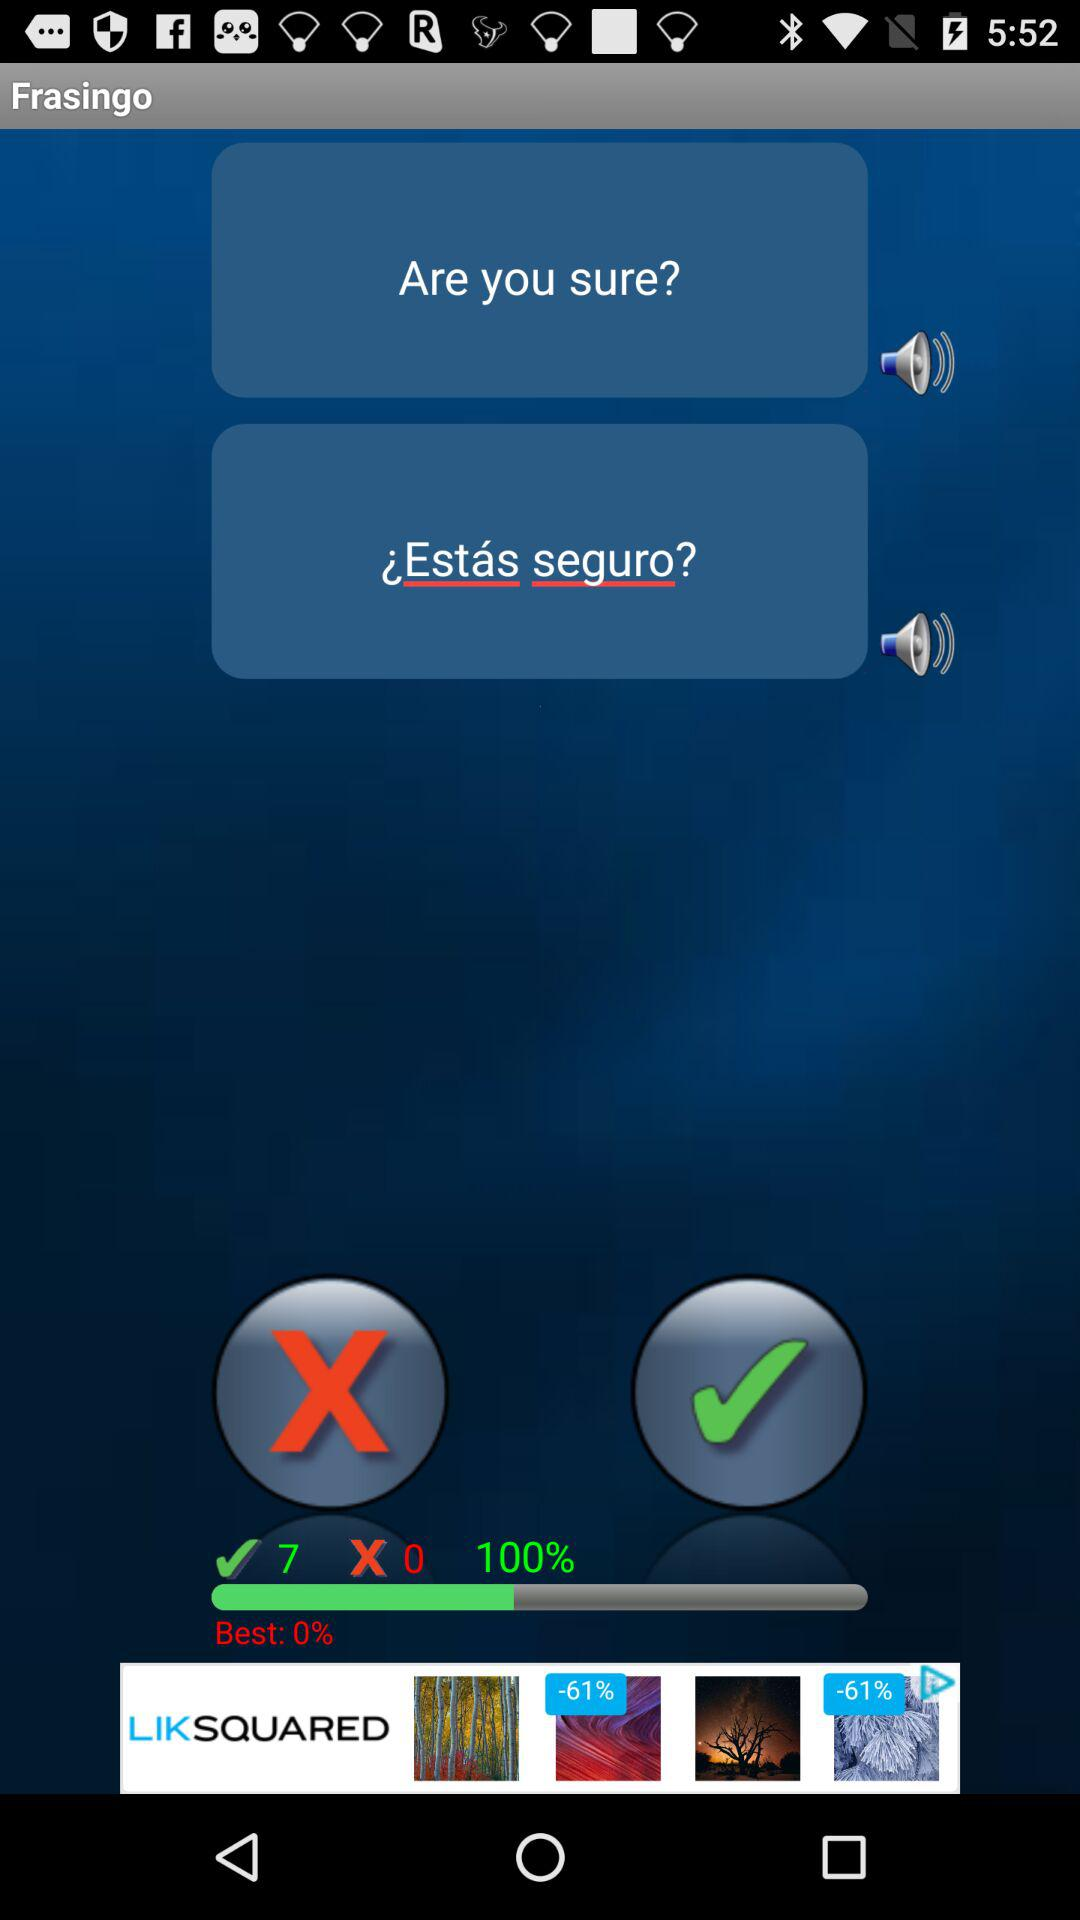How many volume states are there?
Answer the question using a single word or phrase. 2 